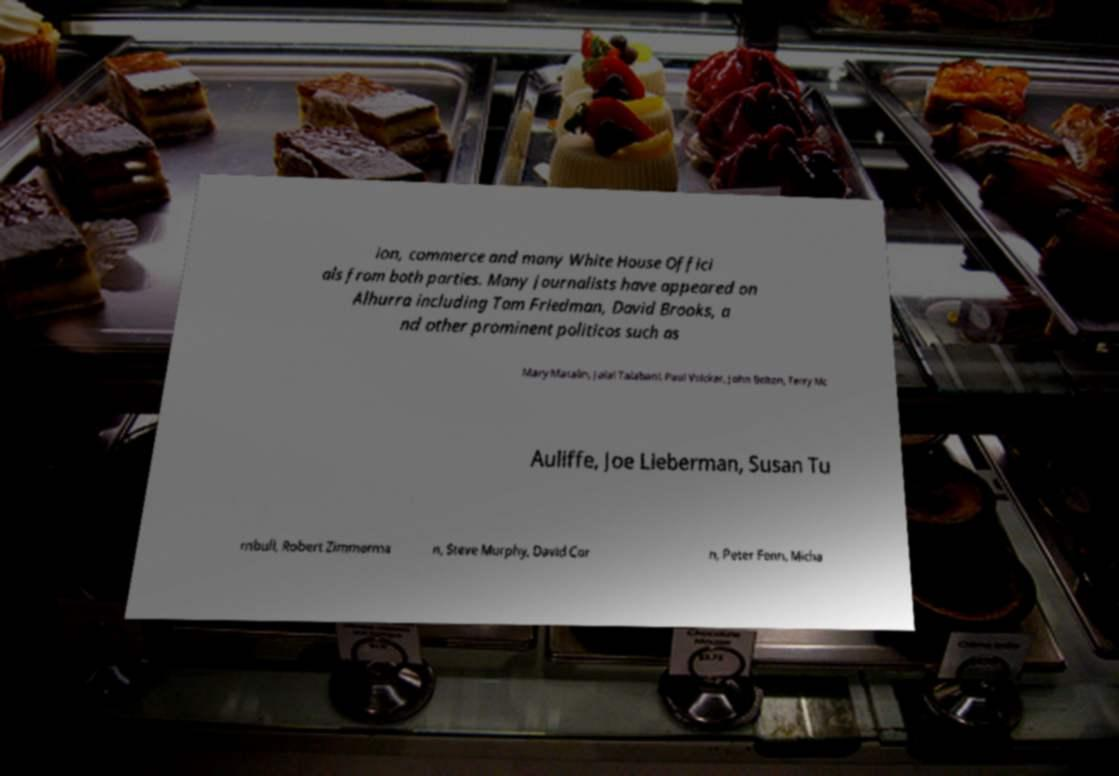What messages or text are displayed in this image? I need them in a readable, typed format. ion, commerce and many White House Offici als from both parties. Many journalists have appeared on Alhurra including Tom Friedman, David Brooks, a nd other prominent politicos such as Mary Matalin, Jalal Talabani, Paul Volcker, John Bolton, Terry Mc Auliffe, Joe Lieberman, Susan Tu rnbull, Robert Zimmerma n, Steve Murphy, David Cor n, Peter Fenn, Micha 